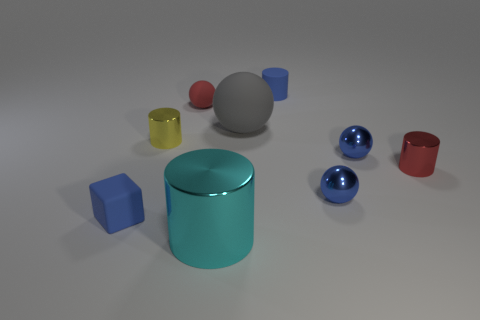What is the shape of the small object that is both behind the yellow metal object and on the right side of the large gray matte thing?
Your response must be concise. Cylinder. There is a shiny thing that is on the left side of the cyan shiny cylinder; is there a small blue shiny thing left of it?
Provide a short and direct response. No. What number of other objects are there of the same material as the tiny yellow cylinder?
Your response must be concise. 4. Is the shape of the small blue rubber thing that is in front of the red ball the same as the big object in front of the small red shiny object?
Provide a succinct answer. No. Are the tiny yellow thing and the big cyan cylinder made of the same material?
Provide a succinct answer. Yes. There is a rubber object in front of the metal cylinder that is right of the big thing that is in front of the gray sphere; what size is it?
Offer a very short reply. Small. What number of other objects are the same color as the big matte ball?
Your answer should be very brief. 0. The red metallic object that is the same size as the yellow metal thing is what shape?
Make the answer very short. Cylinder. How many small objects are cyan metallic objects or yellow cylinders?
Your answer should be very brief. 1. Is there a tiny block that is behind the blue matte thing to the right of the tiny yellow shiny cylinder that is to the right of the tiny blue rubber block?
Offer a very short reply. No. 